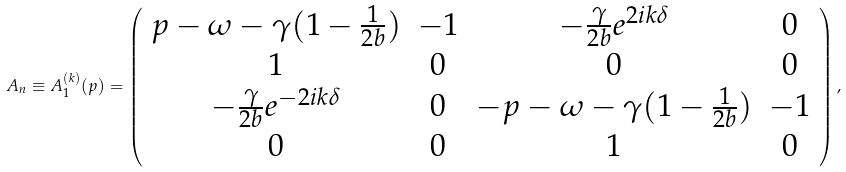Convert formula to latex. <formula><loc_0><loc_0><loc_500><loc_500>A _ { n } \equiv A _ { 1 } ^ { ( k ) } ( p ) = \left ( \begin{array} { c c c c } p - \omega - \gamma ( 1 - \frac { 1 } { 2 b } ) & - 1 & - \frac { \gamma } { 2 b } e ^ { 2 i k \delta } & 0 \\ 1 & 0 & 0 & 0 \\ - \frac { \gamma } { 2 b } e ^ { - 2 i k \delta } & 0 & - p - \omega - \gamma ( 1 - \frac { 1 } { 2 b } ) & - 1 \\ 0 & 0 & 1 & 0 \end{array} \right ) ,</formula> 